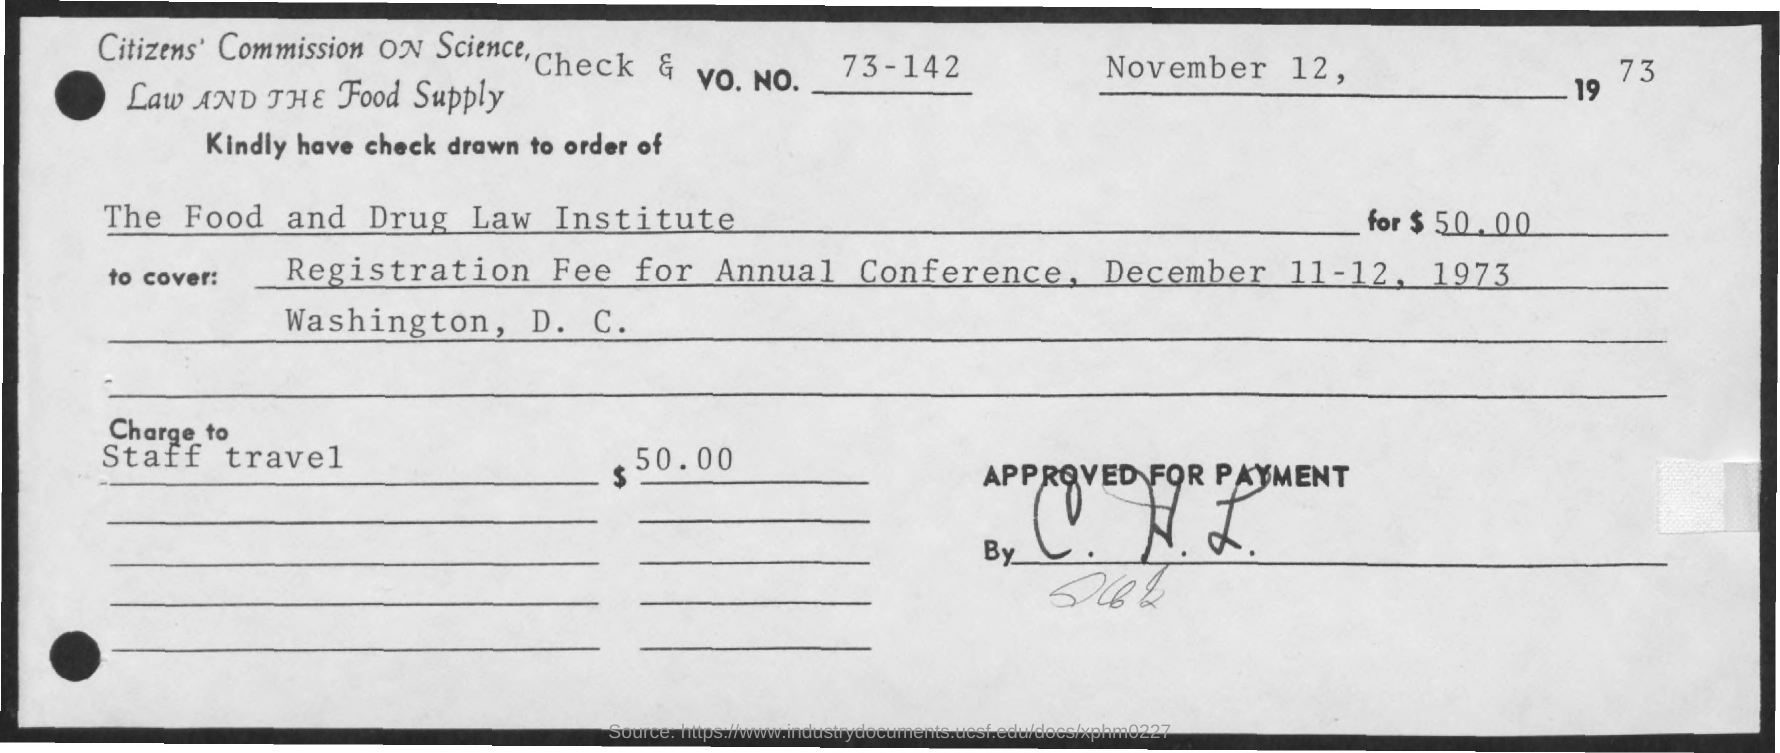What is the Vo. No. mentioned in the check?
Provide a short and direct response. 73-142. What is the amount of check given?
Your response must be concise. 50.00. In which institute name, the check is issued?
Offer a very short reply. The Food and Drug Law Institute. 